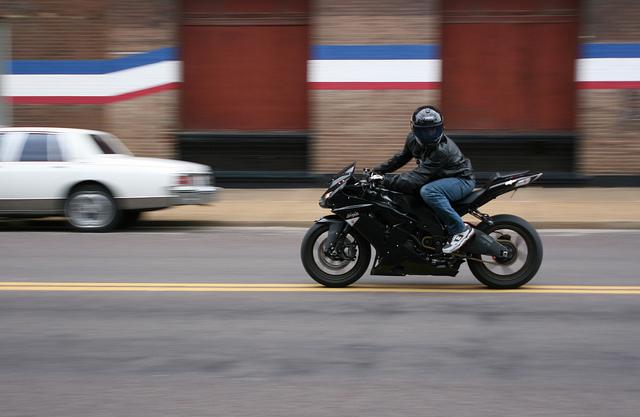Which former country had a flag which looks similar to these banners? Please explain your reasoning. yugoslavia. Yugoslavia is similar. 